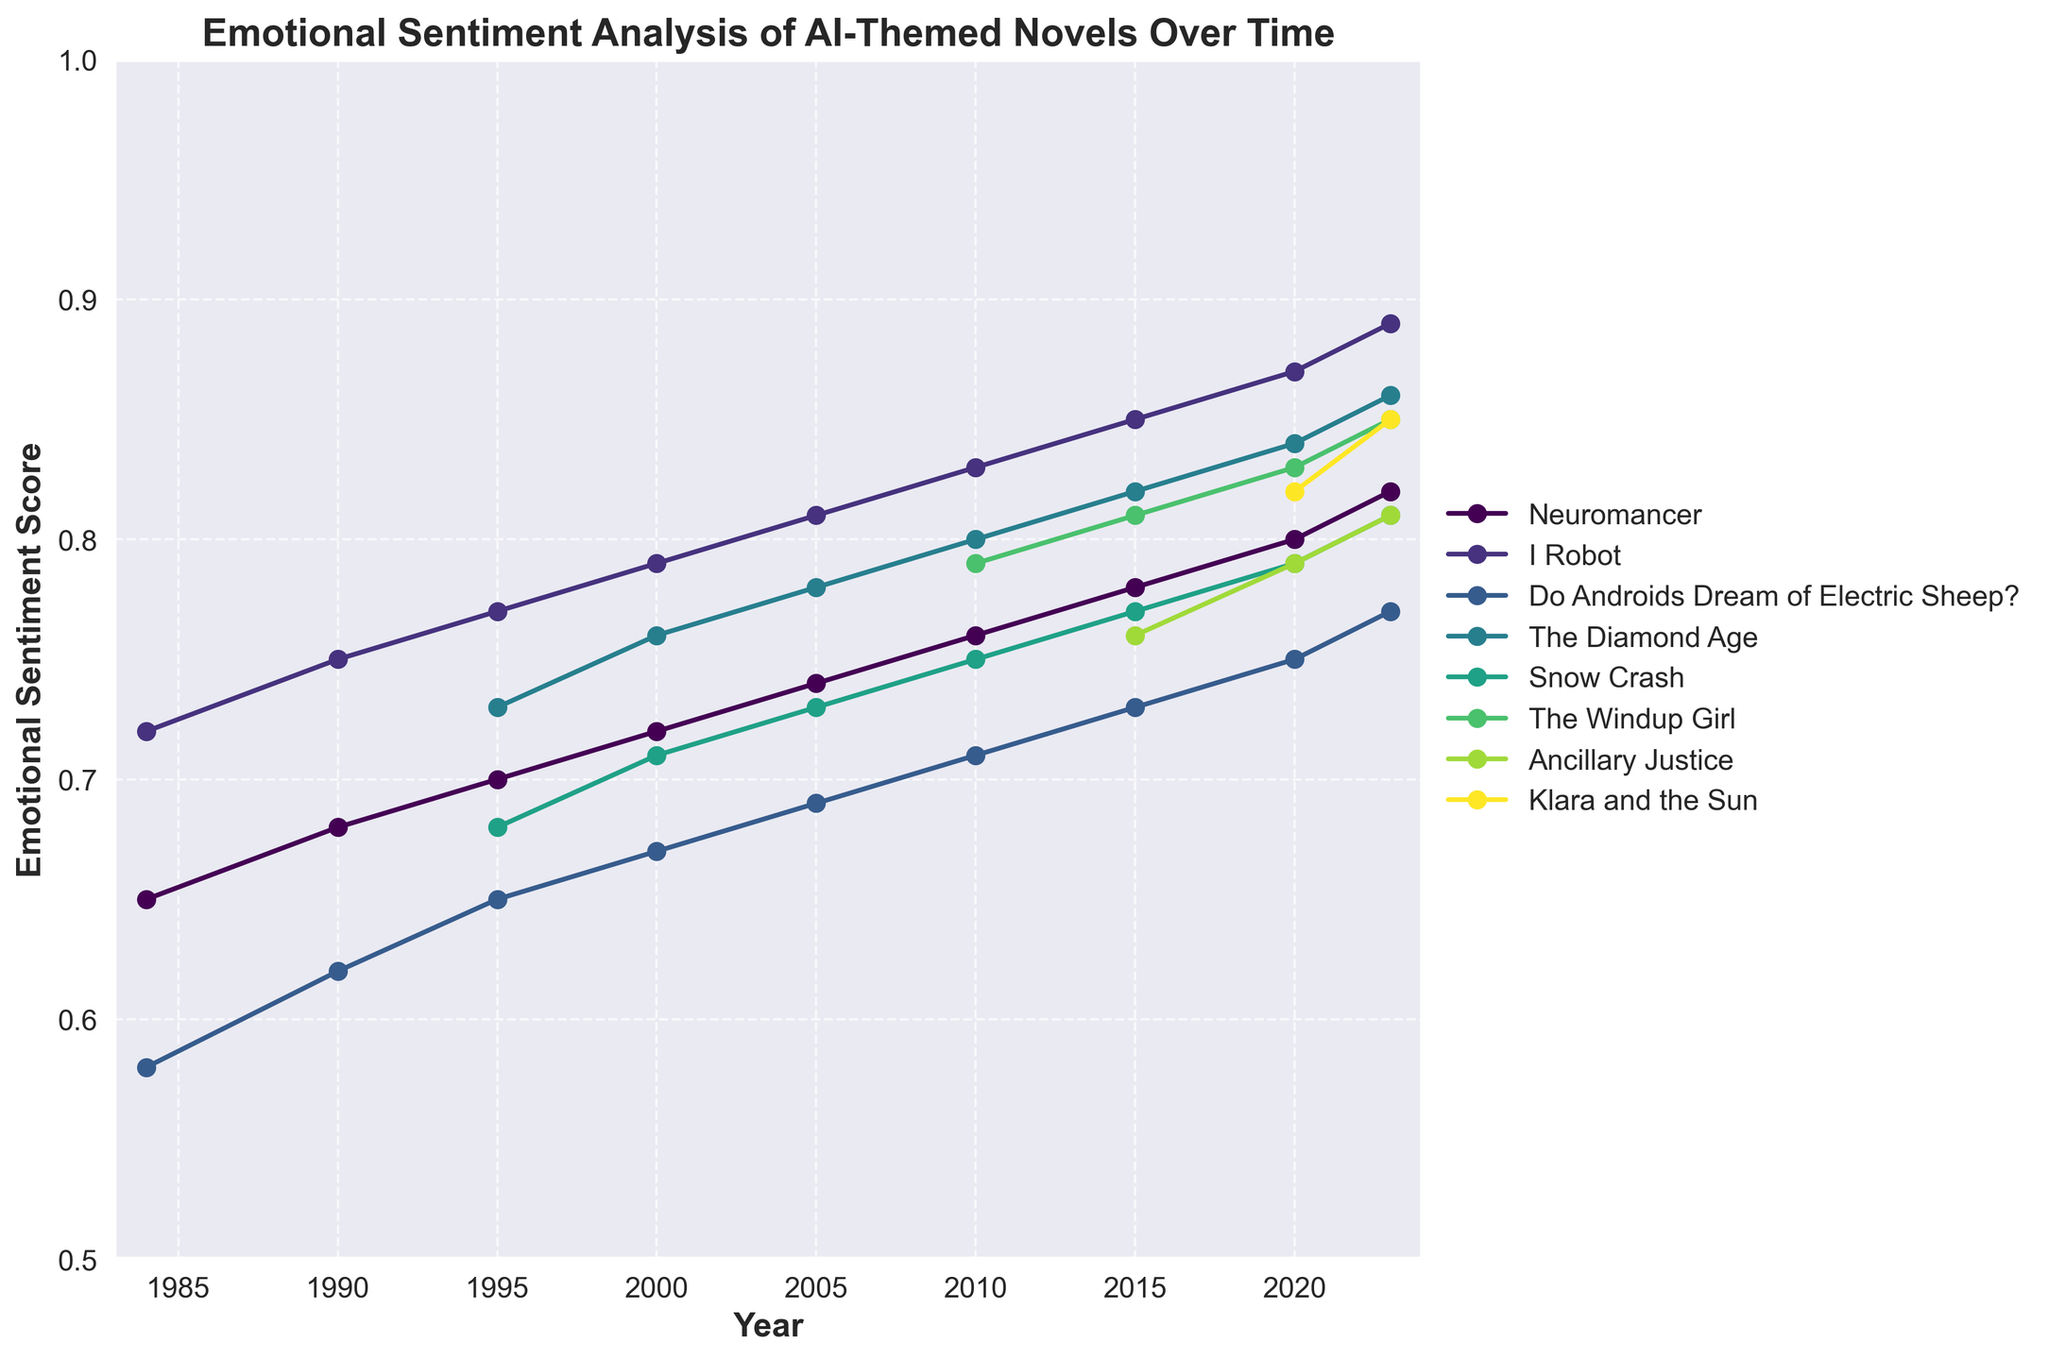What's the highest emotional sentiment score observed for "I Robot"? The highest score for "I Robot" can be found by looking at the point where its curve reaches the maximum value, which happens in 2023 at 0.89.
Answer: 0.89 Which novel showed the greatest increase in emotional sentiment score from 1984 to 2023? The greatest increase is found by comparing the 1984 and 2023 scores for each novel. "Neuromancer" increased from 0.65 to 0.82, "I Robot" from 0.72 to 0.89, and "Do Androids Dream of Electric Sheep?" from 0.58 to 0.77. The highest increase, therefore, is for "I Robot" with a rise of 0.17.
Answer: "I Robot" In which year were the emotional sentiments of "Klara and the Sun" and "The Windup Girl" both recorded for the first time? The first year both novels are recorded can be observed by finding the earliest shared data point for "Klara and the Sun" and "The Windup Girl," which is 2020.
Answer: 2020 What is the average emotional sentiment score for "Snow Crash" from 1995 to 2023? The average score is calculated by summing the emotional sentiments for each year "Snow Crash" is recorded (0.68, 0.71, 0.73, 0.75, 0.77, 0.79, 0.81) and dividing by the number of years, which is 7. The sum is 5.24, so the average is 5.24/7 ≈ 0.75.
Answer: 0.75 How does the emotional sentiment score of "The Diamond Age" in 2023 compare with its score in 2000? By looking at the scores in the respective years, "The Diamond Age" had a sentiment score of 0.86 in 2023 and 0.76 in 2000. Therefore, its score increased by 0.10.
Answer: Increased by 0.10 Which novel had the lowest emotional sentiment score in 1984? The lowest emotional sentiment score in 1984 is found by comparing the scores of the three novels in that year: "Neuromancer" (0.65), "I Robot" (0.72), and "Do Androids Dream of Electric Sheep?" (0.58). The lowest score is for "Do Androids Dream of Electric Sheep?" at 0.58.
Answer: "Do Androids Dream of Electric Sheep?" What is the trend in the emotional sentiment score of "Ancillary Justice" from 2015 to 2023? Observing the curve for "Ancillary Justice" from 2015 to 2023, its scores are 0.76 in 2015, 0.79 in 2020, and 0.81 in 2023. This indicates an upward trend.
Answer: Upward trend Compare the emotional sentiment score of "Neuromancer" and "The Windup Girl" in 2010. The scores for "Neuromancer" and "The Windup Girl" in 2010 are 0.76 and 0.79, respectively. "The Windup Girl" has a higher score.
Answer: "The Windup Girl" has higher score What is the range of emotional sentiment scores for "Do Androids Dream of Electric Sheep?" from 1984 to 2023? The range is found by subtracting the minimum score from the maximum score over the given years. The scores range from a minimum of 0.58 in 1984 to a maximum of 0.77 in 2023. The range is thus 0.77 - 0.58 = 0.19.
Answer: 0.19 